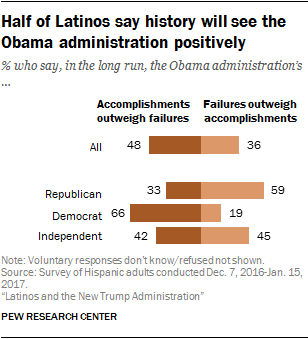Mention a couple of crucial points in this snapshot. The color of the bar with a value of 33 is red. What is the difference between the highest and lowest red bar?" is a question asking for an explanation or comparison of two things, possibly related to data or statistics. 